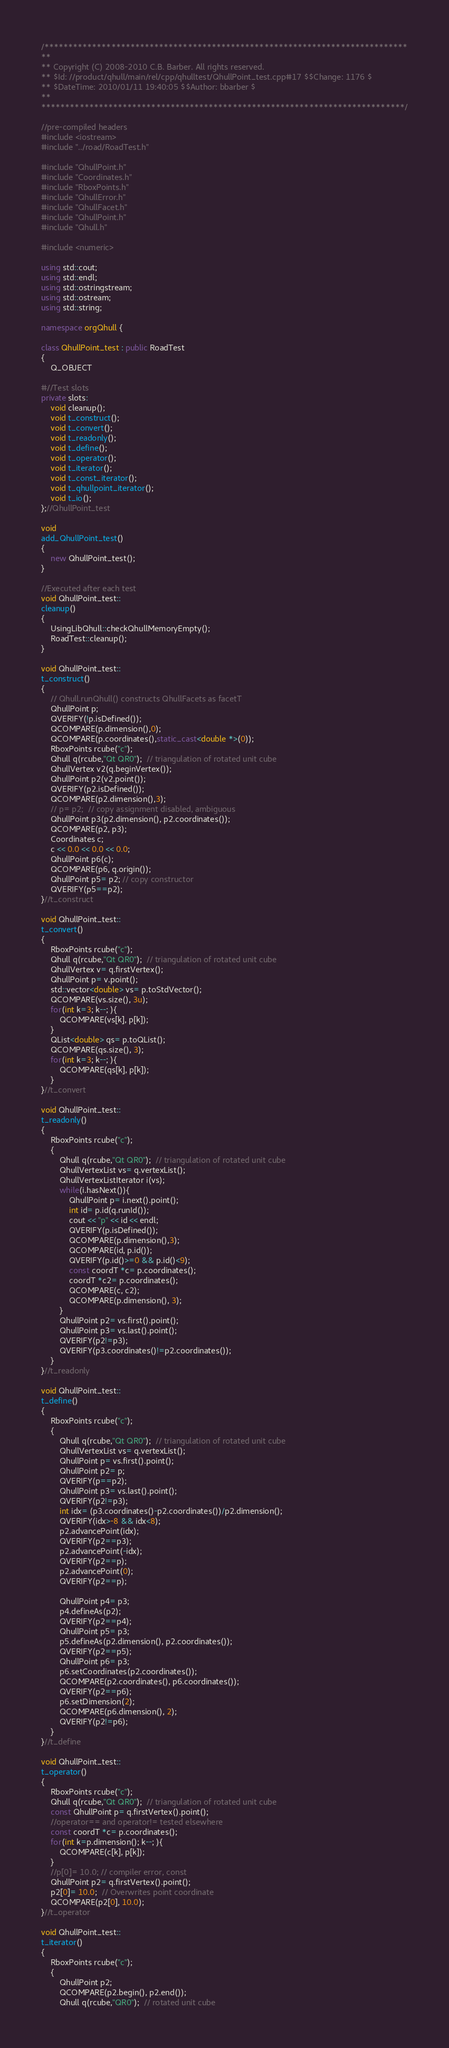<code> <loc_0><loc_0><loc_500><loc_500><_C++_>/****************************************************************************
**
** Copyright (C) 2008-2010 C.B. Barber. All rights reserved.
** $Id: //product/qhull/main/rel/cpp/qhulltest/QhullPoint_test.cpp#17 $$Change: 1176 $
** $DateTime: 2010/01/11 19:40:05 $$Author: bbarber $
**
****************************************************************************/

//pre-compiled headers
#include <iostream>
#include "../road/RoadTest.h"

#include "QhullPoint.h"
#include "Coordinates.h"
#include "RboxPoints.h"
#include "QhullError.h"
#include "QhullFacet.h"
#include "QhullPoint.h"
#include "Qhull.h"

#include <numeric>

using std::cout;
using std::endl;
using std::ostringstream;
using std::ostream;
using std::string;

namespace orgQhull {

class QhullPoint_test : public RoadTest
{
    Q_OBJECT

#//Test slots
private slots:
    void cleanup();
    void t_construct();
    void t_convert();
    void t_readonly();
    void t_define();
    void t_operator();
    void t_iterator();
    void t_const_iterator();
    void t_qhullpoint_iterator();
    void t_io();
};//QhullPoint_test

void
add_QhullPoint_test()
{
    new QhullPoint_test();
}

//Executed after each test
void QhullPoint_test::
cleanup()
{
    UsingLibQhull::checkQhullMemoryEmpty();
    RoadTest::cleanup();
}

void QhullPoint_test::
t_construct()
{
    // Qhull.runQhull() constructs QhullFacets as facetT
    QhullPoint p;
    QVERIFY(!p.isDefined());
    QCOMPARE(p.dimension(),0);
    QCOMPARE(p.coordinates(),static_cast<double *>(0));
    RboxPoints rcube("c");
    Qhull q(rcube,"Qt QR0");  // triangulation of rotated unit cube
    QhullVertex v2(q.beginVertex());
    QhullPoint p2(v2.point());
    QVERIFY(p2.isDefined());
    QCOMPARE(p2.dimension(),3);
    // p= p2;  // copy assignment disabled, ambiguous
    QhullPoint p3(p2.dimension(), p2.coordinates());
    QCOMPARE(p2, p3);
    Coordinates c;
    c << 0.0 << 0.0 << 0.0;
    QhullPoint p6(c);
    QCOMPARE(p6, q.origin());
    QhullPoint p5= p2; // copy constructor
    QVERIFY(p5==p2);
}//t_construct

void QhullPoint_test::
t_convert()
{
    RboxPoints rcube("c");
    Qhull q(rcube,"Qt QR0");  // triangulation of rotated unit cube
    QhullVertex v= q.firstVertex();
    QhullPoint p= v.point();
    std::vector<double> vs= p.toStdVector();
    QCOMPARE(vs.size(), 3u);
    for(int k=3; k--; ){
        QCOMPARE(vs[k], p[k]);
    }
    QList<double> qs= p.toQList();
    QCOMPARE(qs.size(), 3);
    for(int k=3; k--; ){
        QCOMPARE(qs[k], p[k]);
    }
}//t_convert

void QhullPoint_test::
t_readonly()
{
    RboxPoints rcube("c");
    {
        Qhull q(rcube,"Qt QR0");  // triangulation of rotated unit cube
        QhullVertexList vs= q.vertexList();
        QhullVertexListIterator i(vs);
        while(i.hasNext()){
            QhullPoint p= i.next().point();
            int id= p.id(q.runId());
            cout << "p" << id << endl;
            QVERIFY(p.isDefined());
            QCOMPARE(p.dimension(),3);
            QCOMPARE(id, p.id());
            QVERIFY(p.id()>=0 && p.id()<9);
            const coordT *c= p.coordinates();
            coordT *c2= p.coordinates();
            QCOMPARE(c, c2);
            QCOMPARE(p.dimension(), 3);
        }
        QhullPoint p2= vs.first().point();
        QhullPoint p3= vs.last().point();
        QVERIFY(p2!=p3);
        QVERIFY(p3.coordinates()!=p2.coordinates());
    }
}//t_readonly

void QhullPoint_test::
t_define()
{
    RboxPoints rcube("c");
    {
        Qhull q(rcube,"Qt QR0");  // triangulation of rotated unit cube
        QhullVertexList vs= q.vertexList();
        QhullPoint p= vs.first().point();
        QhullPoint p2= p;
        QVERIFY(p==p2);
        QhullPoint p3= vs.last().point();
        QVERIFY(p2!=p3);
        int idx= (p3.coordinates()-p2.coordinates())/p2.dimension();
        QVERIFY(idx>-8 && idx<8);
        p2.advancePoint(idx);
        QVERIFY(p2==p3);
        p2.advancePoint(-idx);
        QVERIFY(p2==p);
        p2.advancePoint(0);
        QVERIFY(p2==p);

        QhullPoint p4= p3;
        p4.defineAs(p2);
        QVERIFY(p2==p4);
        QhullPoint p5= p3;
        p5.defineAs(p2.dimension(), p2.coordinates());
        QVERIFY(p2==p5);
        QhullPoint p6= p3;
        p6.setCoordinates(p2.coordinates());
        QCOMPARE(p2.coordinates(), p6.coordinates());
        QVERIFY(p2==p6);
        p6.setDimension(2);
        QCOMPARE(p6.dimension(), 2);
        QVERIFY(p2!=p6);
    }
}//t_define

void QhullPoint_test::
t_operator()
{
    RboxPoints rcube("c");
    Qhull q(rcube,"Qt QR0");  // triangulation of rotated unit cube
    const QhullPoint p= q.firstVertex().point();
    //operator== and operator!= tested elsewhere
    const coordT *c= p.coordinates();
    for(int k=p.dimension(); k--; ){
        QCOMPARE(c[k], p[k]);
    }
    //p[0]= 10.0; // compiler error, const
    QhullPoint p2= q.firstVertex().point();
    p2[0]= 10.0;  // Overwrites point coordinate
    QCOMPARE(p2[0], 10.0);
}//t_operator

void QhullPoint_test::
t_iterator()
{
    RboxPoints rcube("c");
    {
        QhullPoint p2;
        QCOMPARE(p2.begin(), p2.end());
        Qhull q(rcube,"QR0");  // rotated unit cube</code> 